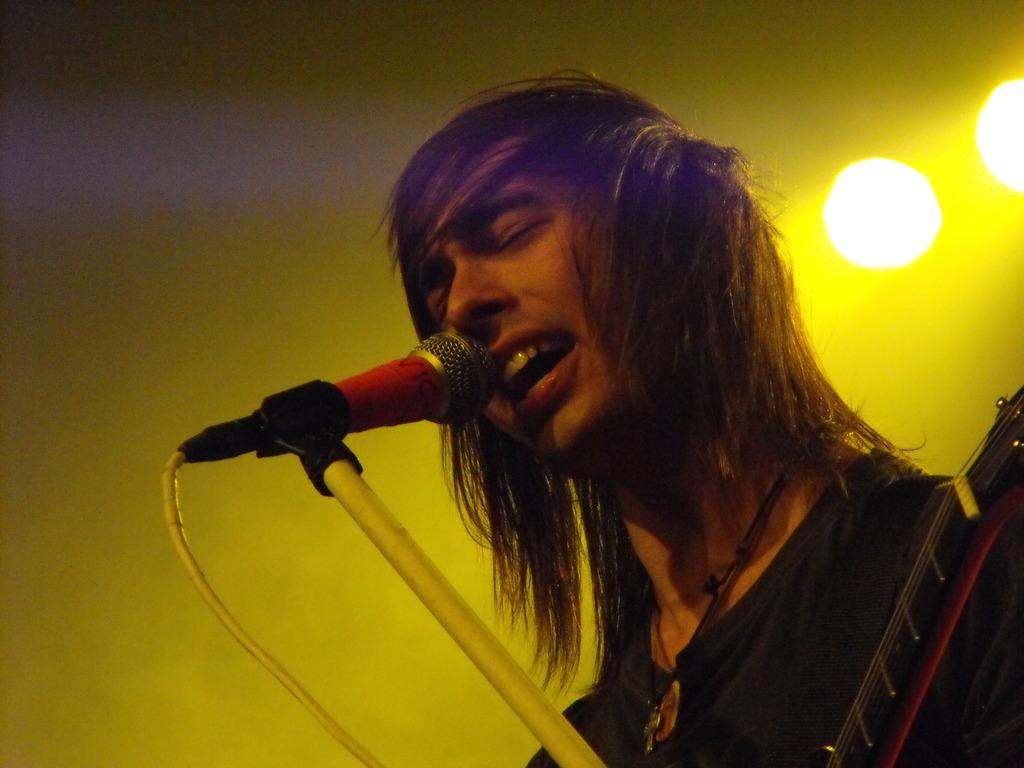What is the person in the image doing? The person is holding a guitar and singing through a microphone. What instrument is the person playing? The person is playing a guitar. What can be seen in the background of the image? There are lights visible in the background of the image. How many toes are visible on the lizards in the image? There are no lizards present in the image, so it is not possible to determine the number of toes visible on them. 